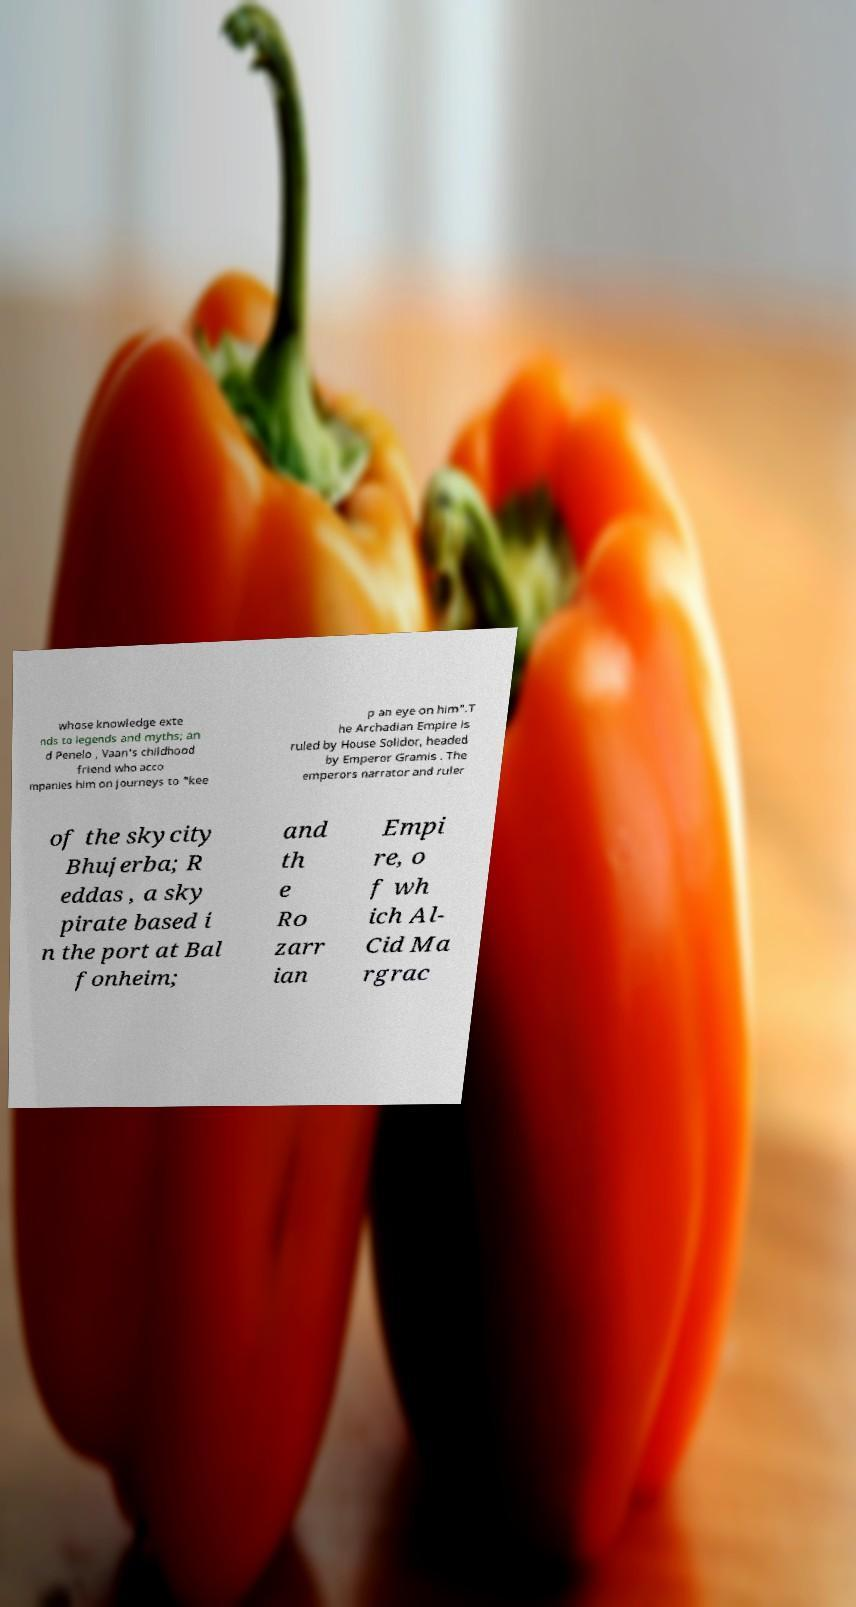Can you accurately transcribe the text from the provided image for me? whose knowledge exte nds to legends and myths; an d Penelo , Vaan's childhood friend who acco mpanies him on journeys to "kee p an eye on him".T he Archadian Empire is ruled by House Solidor, headed by Emperor Gramis . The emperors narrator and ruler of the skycity Bhujerba; R eddas , a sky pirate based i n the port at Bal fonheim; and th e Ro zarr ian Empi re, o f wh ich Al- Cid Ma rgrac 